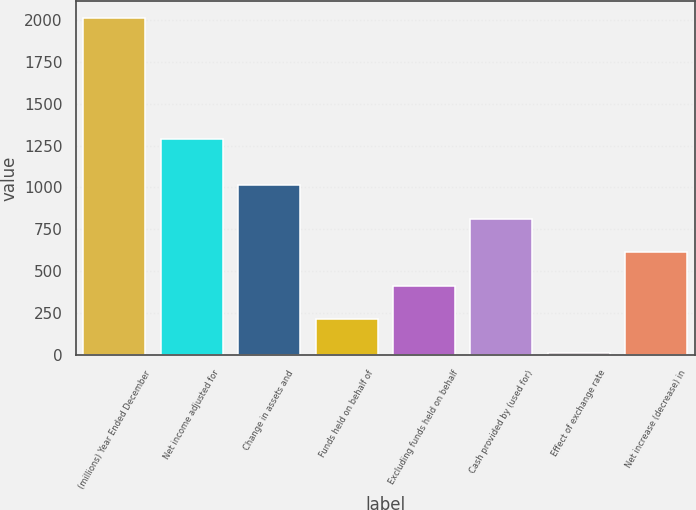<chart> <loc_0><loc_0><loc_500><loc_500><bar_chart><fcel>(millions) Year Ended December<fcel>Net income adjusted for<fcel>Change in assets and<fcel>Funds held on behalf of<fcel>Excluding funds held on behalf<fcel>Cash provided by (used for)<fcel>Effect of exchange rate<fcel>Net increase (decrease) in<nl><fcel>2009<fcel>1290<fcel>1012.5<fcel>215.3<fcel>414.6<fcel>813.2<fcel>16<fcel>613.9<nl></chart> 